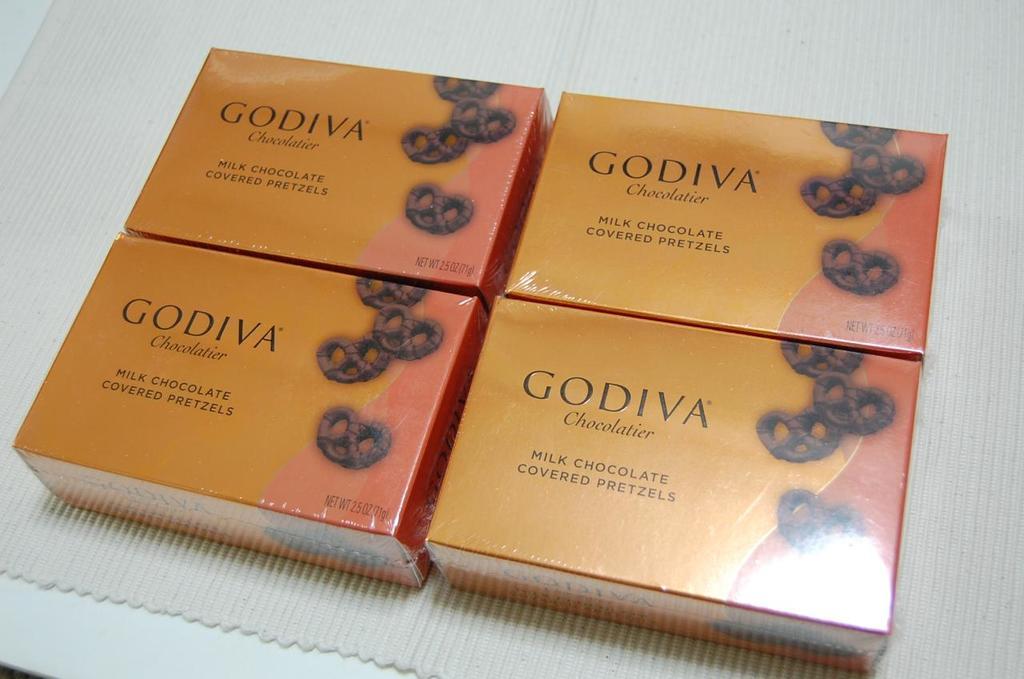What brand are these chocolate?
Offer a very short reply. Godiva. What is the shape of the chocolate?
Give a very brief answer. Answering does not require reading text in the image. 